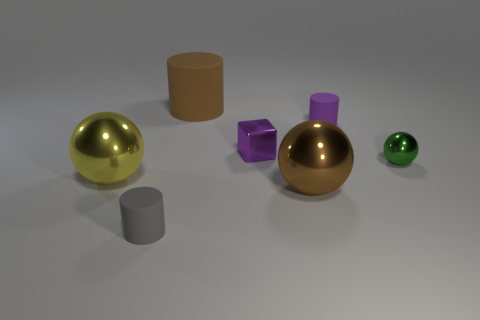Are there any things that have the same color as the big cylinder?
Your response must be concise. Yes. Is the small sphere behind the big yellow ball made of the same material as the large ball behind the big brown metallic sphere?
Offer a very short reply. Yes. What number of purple matte things are the same size as the green metallic object?
Your response must be concise. 1. What is the shape of the metal thing that is the same color as the big rubber cylinder?
Keep it short and to the point. Sphere. What material is the large ball that is left of the brown rubber thing?
Your answer should be very brief. Metal. What number of other small metal objects have the same shape as the brown metal object?
Your response must be concise. 1. There is a big yellow object that is the same material as the large brown ball; what shape is it?
Give a very brief answer. Sphere. The small matte object that is behind the cylinder that is in front of the small metal thing to the left of the green ball is what shape?
Offer a very short reply. Cylinder. Is the number of large brown rubber cylinders greater than the number of tiny red metal balls?
Your answer should be very brief. Yes. There is a gray object that is the same shape as the brown rubber thing; what is its material?
Make the answer very short. Rubber. 